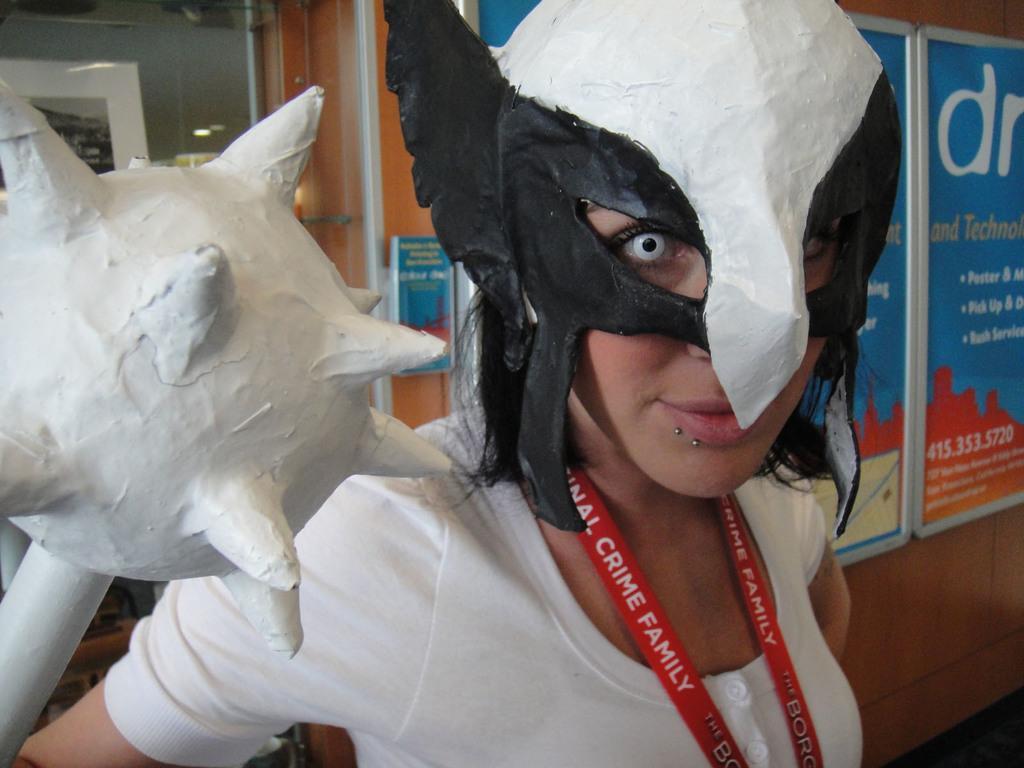Can you describe this image briefly? Here we can see a woman and she wore a mask. She is holding an object with her hand. In the background we can see boards, glass, and wall. 